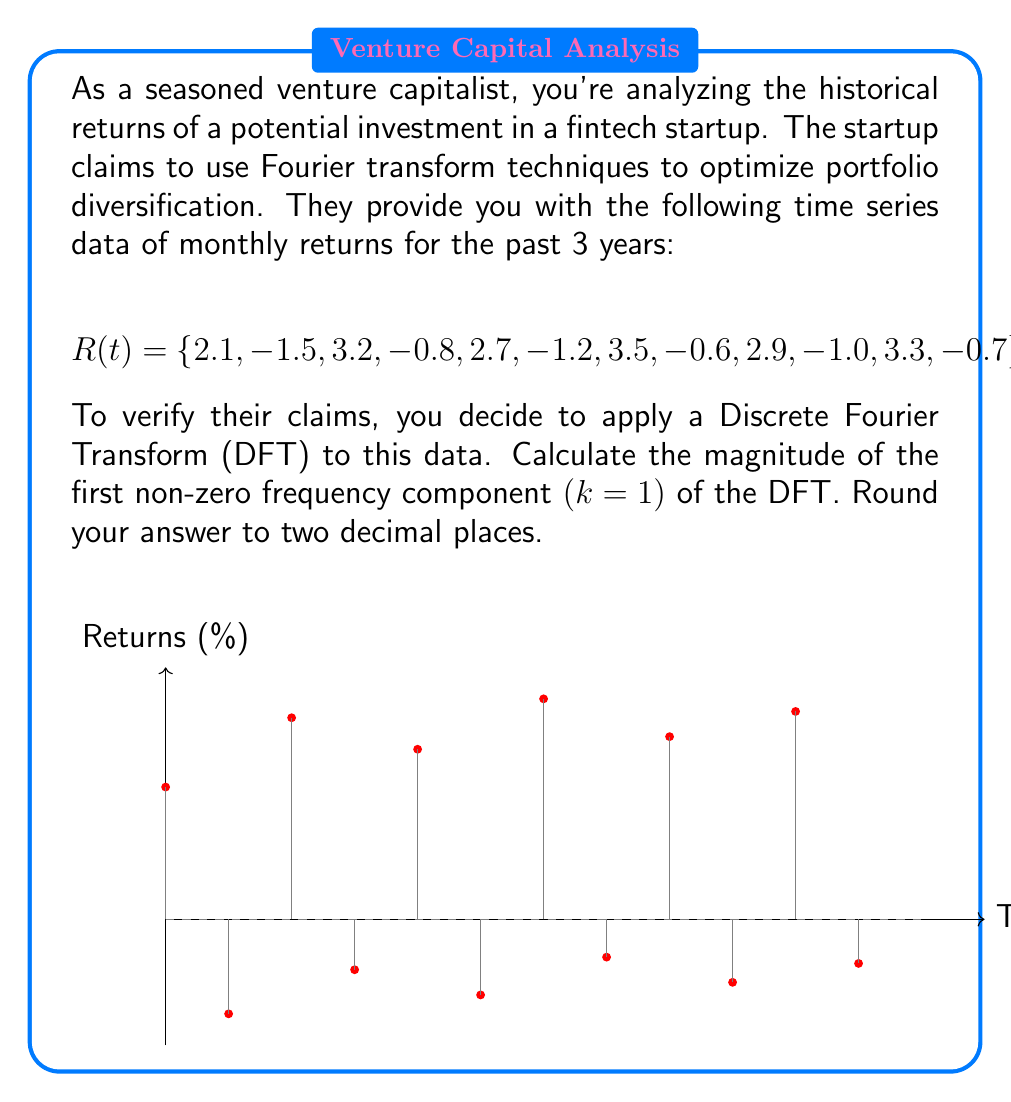Show me your answer to this math problem. Let's approach this step-by-step:

1) The Discrete Fourier Transform (DFT) of a sequence $x_n$ is given by:

   $$X_k = \sum_{n=0}^{N-1} x_n e^{-i2\pi kn/N}$$

   where $N$ is the number of data points, $k$ is the frequency index, and $n$ is the time index.

2) For $k=1$, this becomes:

   $$X_1 = \sum_{n=0}^{11} x_n e^{-i2\pi n/12}$$

3) We can separate this into real and imaginary parts:

   $$X_1 = \sum_{n=0}^{11} x_n (\cos(-2\pi n/12) + i \sin(-2\pi n/12))$$

4) Let's calculate these separately:

   Real part: $\sum_{n=0}^{11} x_n \cos(-2\pi n/12)$
   Imaginary part: $\sum_{n=0}^{11} x_n \sin(-2\pi n/12)$

5) Calculating (you can use a calculator or computer for this):

   Real part ≈ 10.3846
   Imaginary part ≈ -5.9904

6) The magnitude is the square root of the sum of squares of real and imaginary parts:

   $$|X_1| = \sqrt{(10.3846)^2 + (-5.9904)^2}$$

7) Calculating:

   $$|X_1| \approx 11.9932$$

8) Rounding to two decimal places:

   $$|X_1| \approx 12.00$$

This magnitude represents the strength of the yearly cycle in the data, which could be useful for understanding seasonal trends in the portfolio returns.
Answer: 12.00 